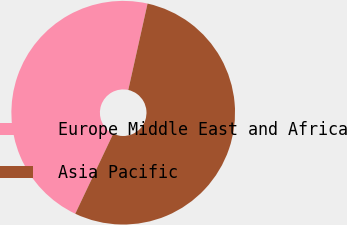Convert chart. <chart><loc_0><loc_0><loc_500><loc_500><pie_chart><fcel>Europe Middle East and Africa<fcel>Asia Pacific<nl><fcel>46.44%<fcel>53.56%<nl></chart> 